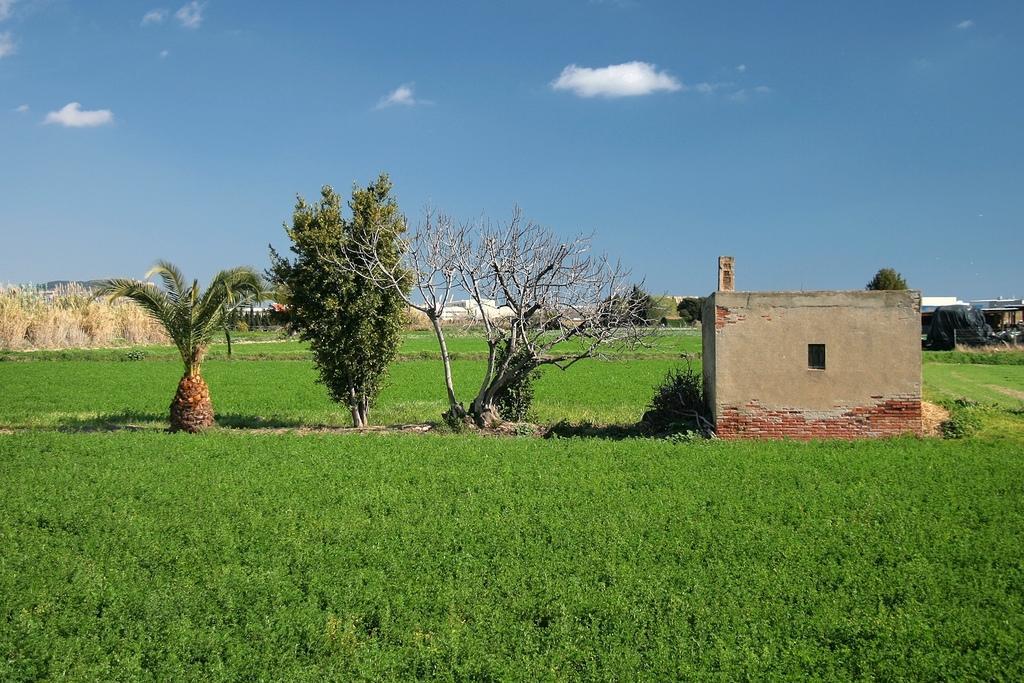In one or two sentences, can you explain what this image depicts? In this image I can see few trees,house and dry grass. The sky is in white and blue color. 